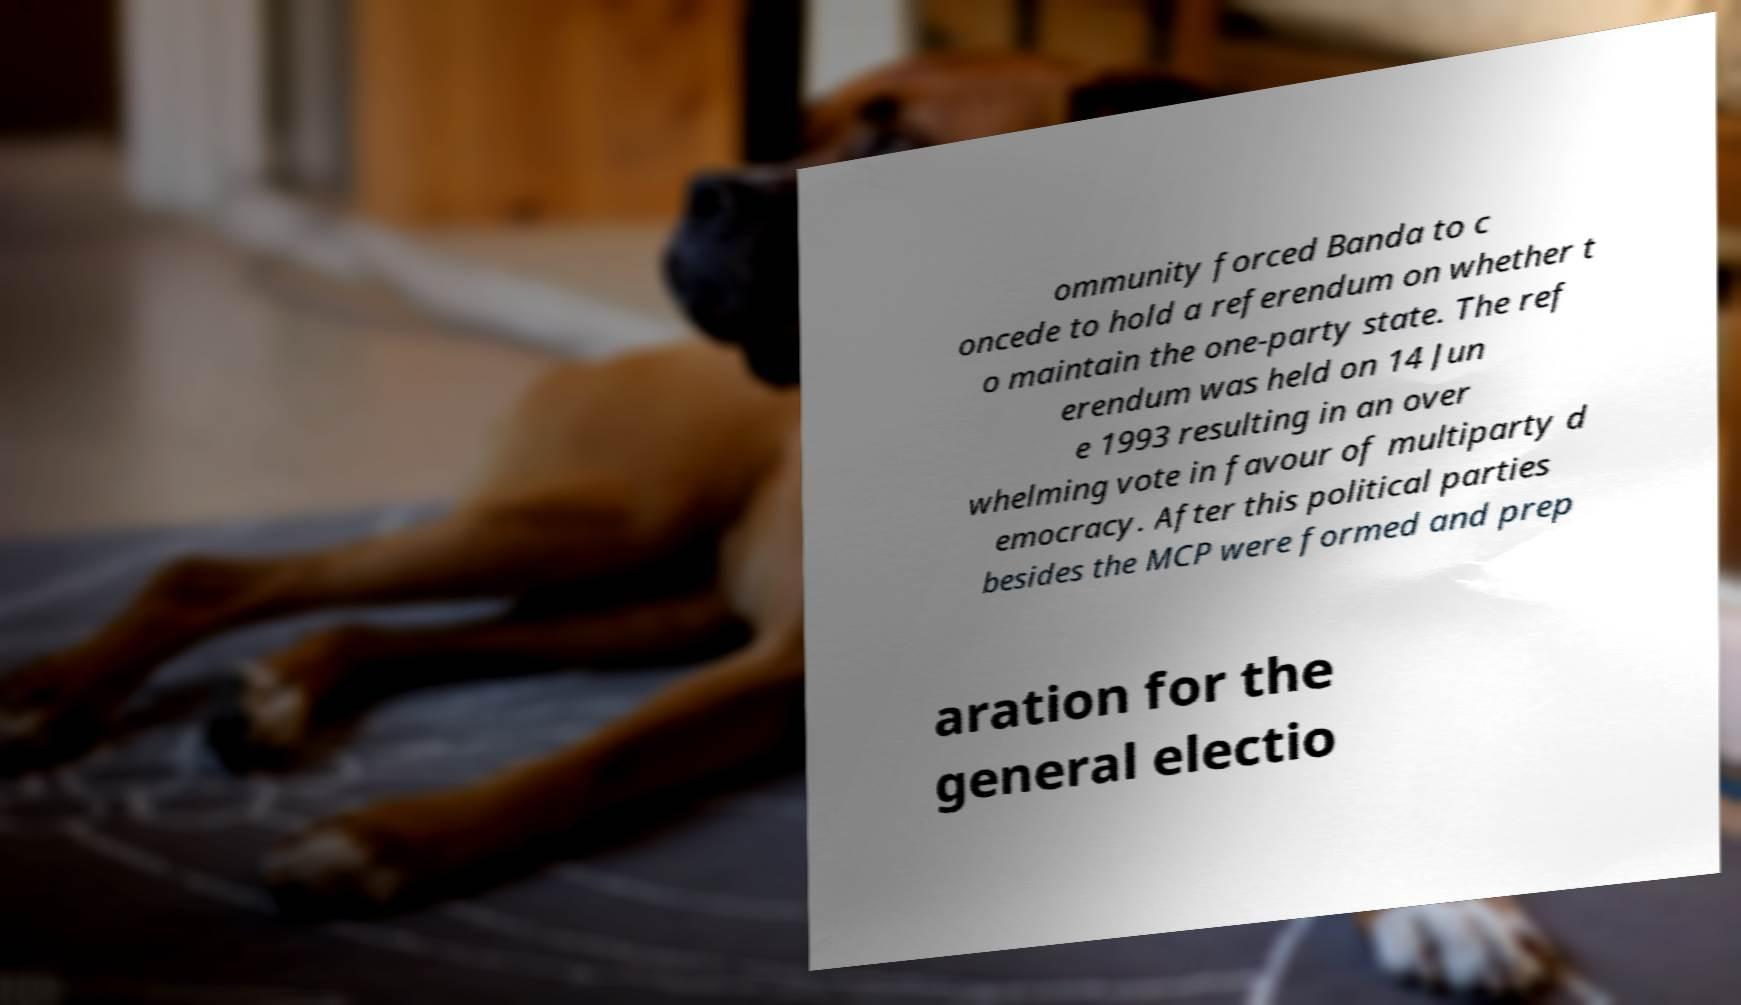Please read and relay the text visible in this image. What does it say? ommunity forced Banda to c oncede to hold a referendum on whether t o maintain the one-party state. The ref erendum was held on 14 Jun e 1993 resulting in an over whelming vote in favour of multiparty d emocracy. After this political parties besides the MCP were formed and prep aration for the general electio 